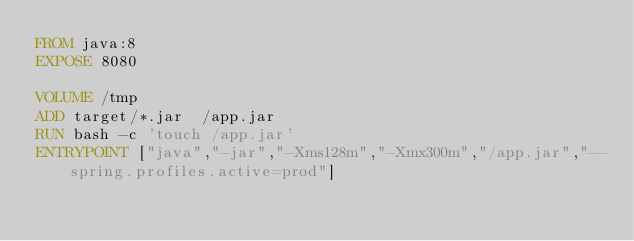<code> <loc_0><loc_0><loc_500><loc_500><_Dockerfile_>FROM java:8
EXPOSE 8080

VOLUME /tmp
ADD target/*.jar  /app.jar
RUN bash -c 'touch /app.jar'
ENTRYPOINT ["java","-jar","-Xms128m","-Xmx300m","/app.jar","--spring.profiles.active=prod"]
</code> 